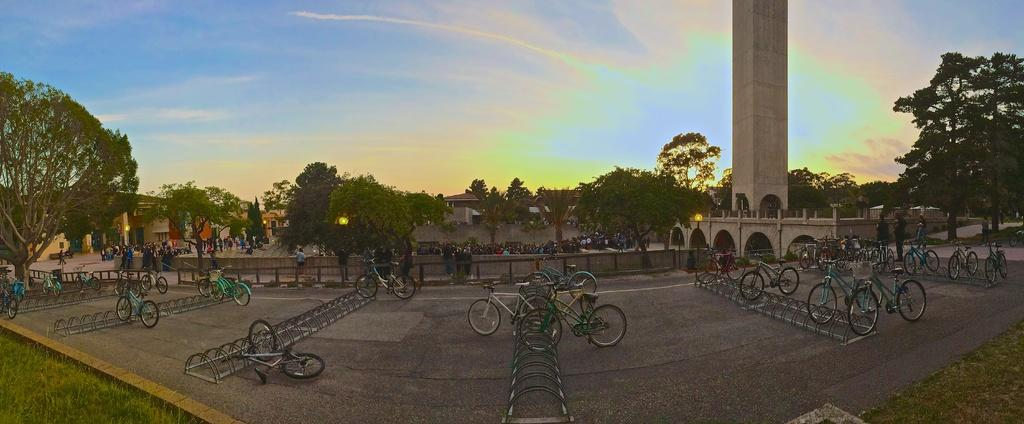What type of vehicles can be seen on the road in the image? There are bicycles on the road in the image. What type of vegetation is present in the image? There are trees and grass in the image. What type of barrier is visible in the image? There is a fence in the image. What type of structure can be seen in the image? There is a tower in the image. What type of man-made structures are present in the image? There are buildings in the image. Who or what is present in the image? There is a group of people in the image. What is visible in the background of the image? The sky is visible in the background of the image. What can be seen in the sky? There are clouds in the sky. What type of curtain is hanging from the tower in the image? There is no curtain hanging from the tower in the image. How does the group of people step on the bicycles in the image? The group of people is not stepping on the bicycles in the image; they are simply present in the image. 